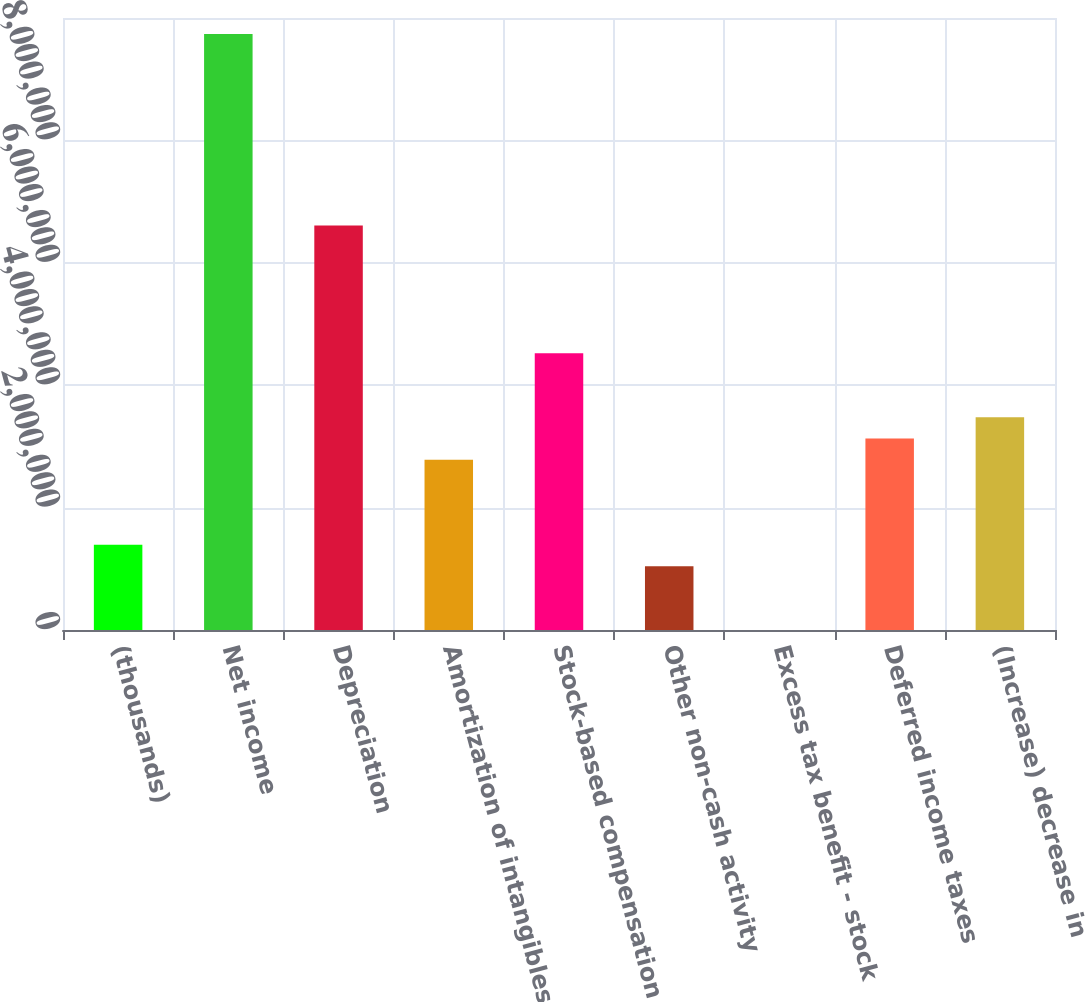<chart> <loc_0><loc_0><loc_500><loc_500><bar_chart><fcel>(thousands)<fcel>Net income<fcel>Depreciation<fcel>Amortization of intangibles<fcel>Stock-based compensation<fcel>Other non-cash activity<fcel>Excess tax benefit - stock<fcel>Deferred income taxes<fcel>(Increase) decrease in<nl><fcel>1.3914e+06<fcel>9.7379e+06<fcel>6.60796e+06<fcel>2.78248e+06<fcel>4.52134e+06<fcel>1.04363e+06<fcel>317<fcel>3.13025e+06<fcel>3.47802e+06<nl></chart> 